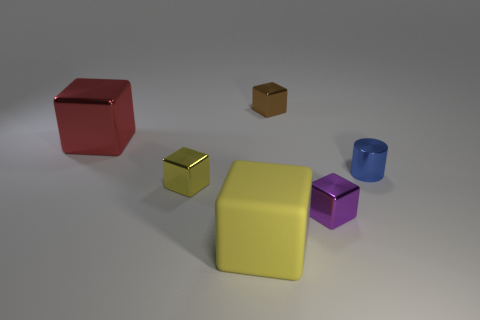Subtract all yellow blocks. How many were subtracted if there are1yellow blocks left? 1 Subtract all brown metallic cubes. How many cubes are left? 4 Subtract all brown cubes. How many cubes are left? 4 Add 1 tiny green rubber objects. How many objects exist? 7 Subtract all cylinders. How many objects are left? 5 Subtract 1 cylinders. How many cylinders are left? 0 Add 5 tiny red matte balls. How many tiny red matte balls exist? 5 Subtract 0 cyan cylinders. How many objects are left? 6 Subtract all cyan cylinders. Subtract all cyan cubes. How many cylinders are left? 1 Subtract all green balls. How many cyan blocks are left? 0 